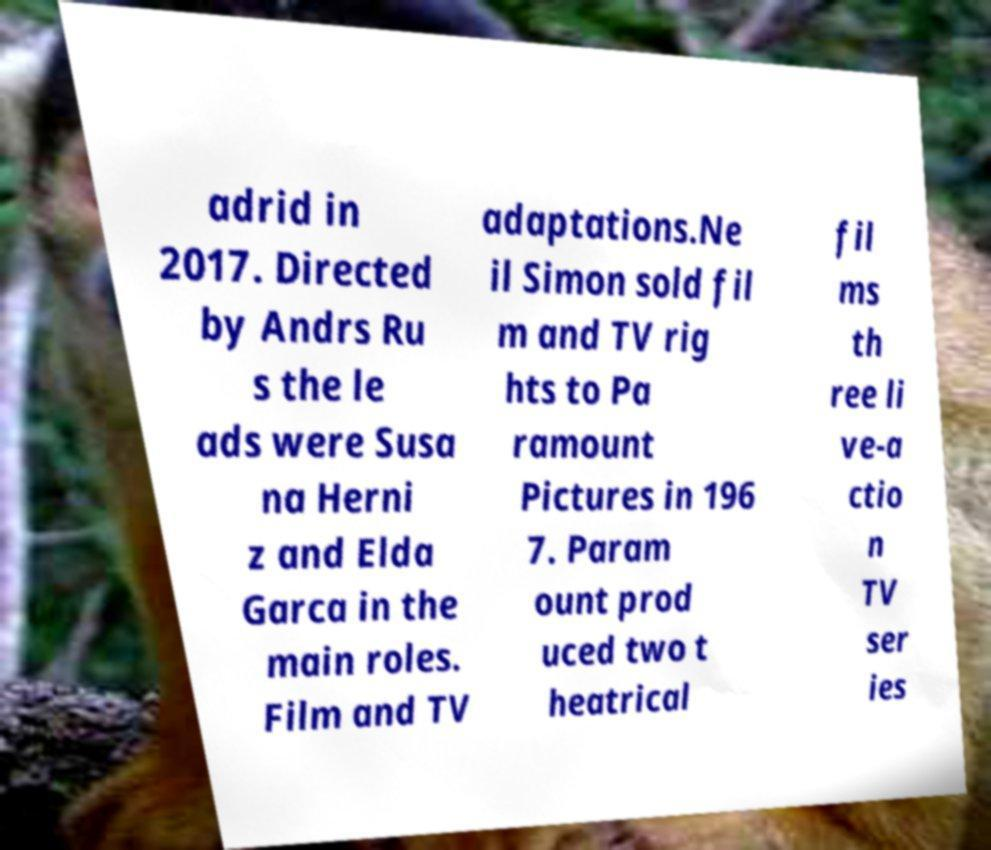Could you assist in decoding the text presented in this image and type it out clearly? adrid in 2017. Directed by Andrs Ru s the le ads were Susa na Herni z and Elda Garca in the main roles. Film and TV adaptations.Ne il Simon sold fil m and TV rig hts to Pa ramount Pictures in 196 7. Param ount prod uced two t heatrical fil ms th ree li ve-a ctio n TV ser ies 